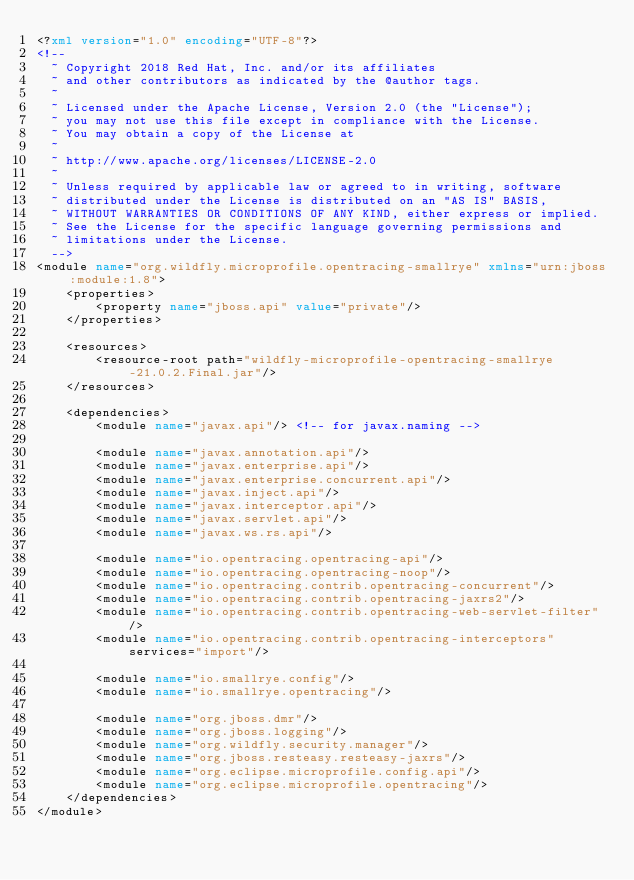<code> <loc_0><loc_0><loc_500><loc_500><_XML_><?xml version="1.0" encoding="UTF-8"?>
<!--
  ~ Copyright 2018 Red Hat, Inc. and/or its affiliates
  ~ and other contributors as indicated by the @author tags.
  ~
  ~ Licensed under the Apache License, Version 2.0 (the "License");
  ~ you may not use this file except in compliance with the License.
  ~ You may obtain a copy of the License at
  ~
  ~ http://www.apache.org/licenses/LICENSE-2.0
  ~
  ~ Unless required by applicable law or agreed to in writing, software
  ~ distributed under the License is distributed on an "AS IS" BASIS,
  ~ WITHOUT WARRANTIES OR CONDITIONS OF ANY KIND, either express or implied.
  ~ See the License for the specific language governing permissions and
  ~ limitations under the License.
  -->
<module name="org.wildfly.microprofile.opentracing-smallrye" xmlns="urn:jboss:module:1.8">
    <properties>
        <property name="jboss.api" value="private"/>
    </properties>

    <resources>
        <resource-root path="wildfly-microprofile-opentracing-smallrye-21.0.2.Final.jar"/>
    </resources>

    <dependencies>
        <module name="javax.api"/> <!-- for javax.naming -->

        <module name="javax.annotation.api"/>
        <module name="javax.enterprise.api"/>
        <module name="javax.enterprise.concurrent.api"/>
        <module name="javax.inject.api"/>
        <module name="javax.interceptor.api"/>
        <module name="javax.servlet.api"/>
        <module name="javax.ws.rs.api"/>

        <module name="io.opentracing.opentracing-api"/>
        <module name="io.opentracing.opentracing-noop"/>
        <module name="io.opentracing.contrib.opentracing-concurrent"/>
        <module name="io.opentracing.contrib.opentracing-jaxrs2"/>
        <module name="io.opentracing.contrib.opentracing-web-servlet-filter"/>
        <module name="io.opentracing.contrib.opentracing-interceptors" services="import"/>

        <module name="io.smallrye.config"/>
        <module name="io.smallrye.opentracing"/>

        <module name="org.jboss.dmr"/>
        <module name="org.jboss.logging"/>
        <module name="org.wildfly.security.manager"/>
        <module name="org.jboss.resteasy.resteasy-jaxrs"/>
        <module name="org.eclipse.microprofile.config.api"/>
        <module name="org.eclipse.microprofile.opentracing"/>
    </dependencies>
</module>
</code> 